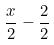<formula> <loc_0><loc_0><loc_500><loc_500>\frac { x } { 2 } - \frac { 2 } { 2 }</formula> 